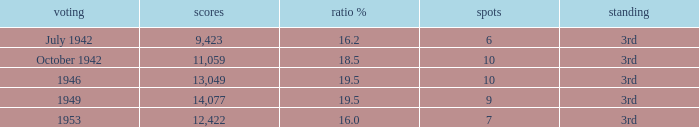Name the total number of seats for votes % more than 19.5 0.0. 